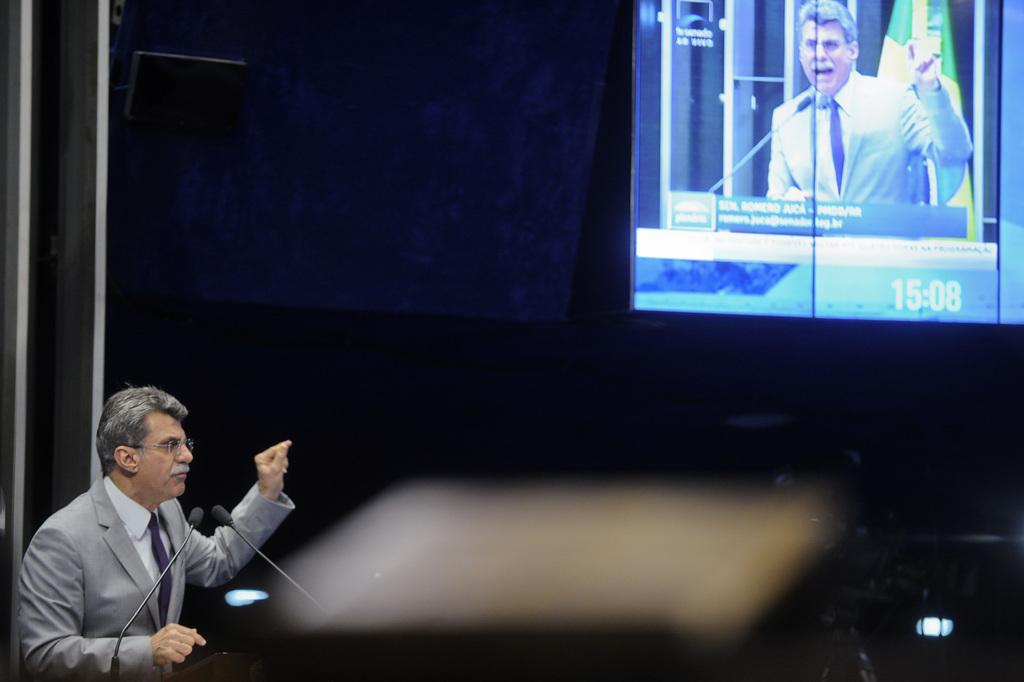What is the time stamp on the screen?
Your response must be concise. 15:08. 